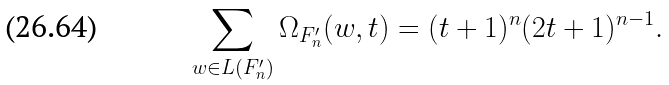Convert formula to latex. <formula><loc_0><loc_0><loc_500><loc_500>\sum _ { w \in L ( F _ { n } ^ { \prime } ) } \Omega _ { F _ { n } ^ { \prime } } ( w , t ) = ( t + 1 ) ^ { n } ( 2 t + 1 ) ^ { n - 1 } .</formula> 